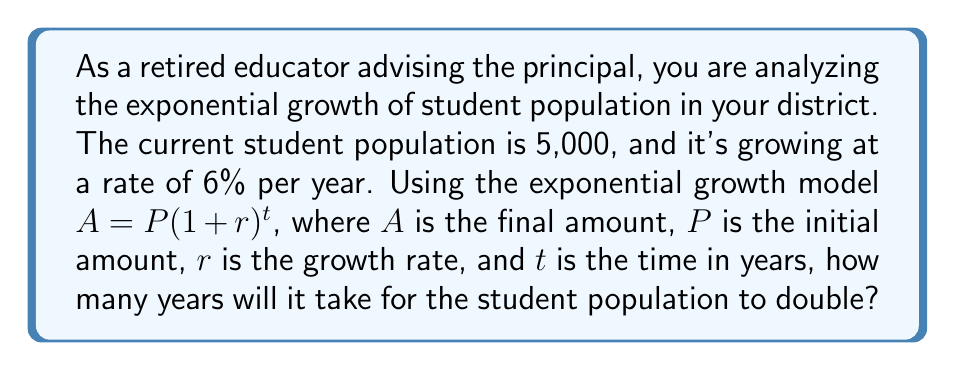Teach me how to tackle this problem. To solve this problem, we'll use the exponential growth formula and the concept of doubling time:

1) The exponential growth formula is:
   $A = P(1 + r)^t$

2) We know:
   $P = 5,000$ (initial population)
   $r = 0.06$ (6% growth rate)
   $A = 2P = 10,000$ (double the initial population)

3) Substituting these values into the formula:
   $10,000 = 5,000(1 + 0.06)^t$

4) Simplify:
   $2 = (1.06)^t$

5) Take the natural logarithm of both sides:
   $\ln(2) = t \cdot \ln(1.06)$

6) Solve for $t$:
   $t = \frac{\ln(2)}{\ln(1.06)}$

7) Calculate:
   $t \approx \frac{0.6931}{0.0583} \approx 11.89$ years

8) Since we can't have a fractional year in this context, we round up to the next whole year.
Answer: It will take 12 years for the student population to double. 